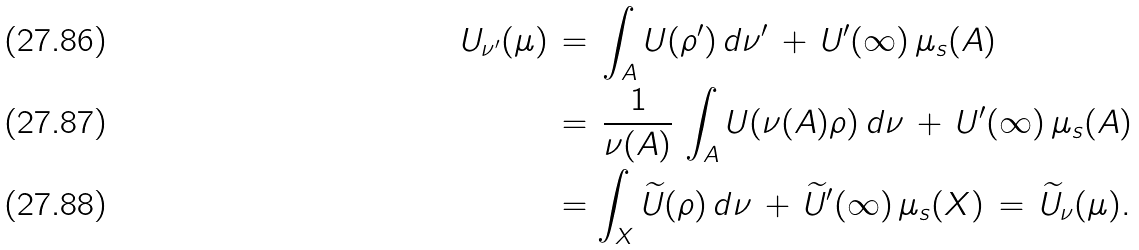Convert formula to latex. <formula><loc_0><loc_0><loc_500><loc_500>U _ { \nu ^ { \prime } } ( \mu ) \, & = \, \int _ { A } U ( \rho ^ { \prime } ) \, d \nu ^ { \prime } \, + \, U ^ { \prime } ( \infty ) \, \mu _ { s } ( A ) \\ & = \, \frac { 1 } { \nu ( A ) } \, \int _ { A } U ( \nu ( A ) \rho ) \, d \nu \, + \, U ^ { \prime } ( \infty ) \, \mu _ { s } ( A ) \\ & = \int _ { X } \widetilde { U } ( \rho ) \, d \nu \, + \, \widetilde { U } ^ { \prime } ( \infty ) \, \mu _ { s } ( X ) \, = \, \widetilde { U } _ { \nu } ( \mu ) .</formula> 